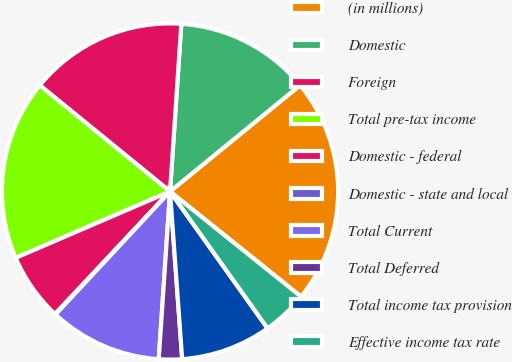Convert chart. <chart><loc_0><loc_0><loc_500><loc_500><pie_chart><fcel>(in millions)<fcel>Domestic<fcel>Foreign<fcel>Total pre-tax income<fcel>Domestic - federal<fcel>Domestic - state and local<fcel>Total Current<fcel>Total Deferred<fcel>Total income tax provision<fcel>Effective income tax rate<nl><fcel>21.66%<fcel>13.02%<fcel>15.18%<fcel>17.34%<fcel>6.54%<fcel>0.06%<fcel>10.86%<fcel>2.22%<fcel>8.7%<fcel>4.38%<nl></chart> 